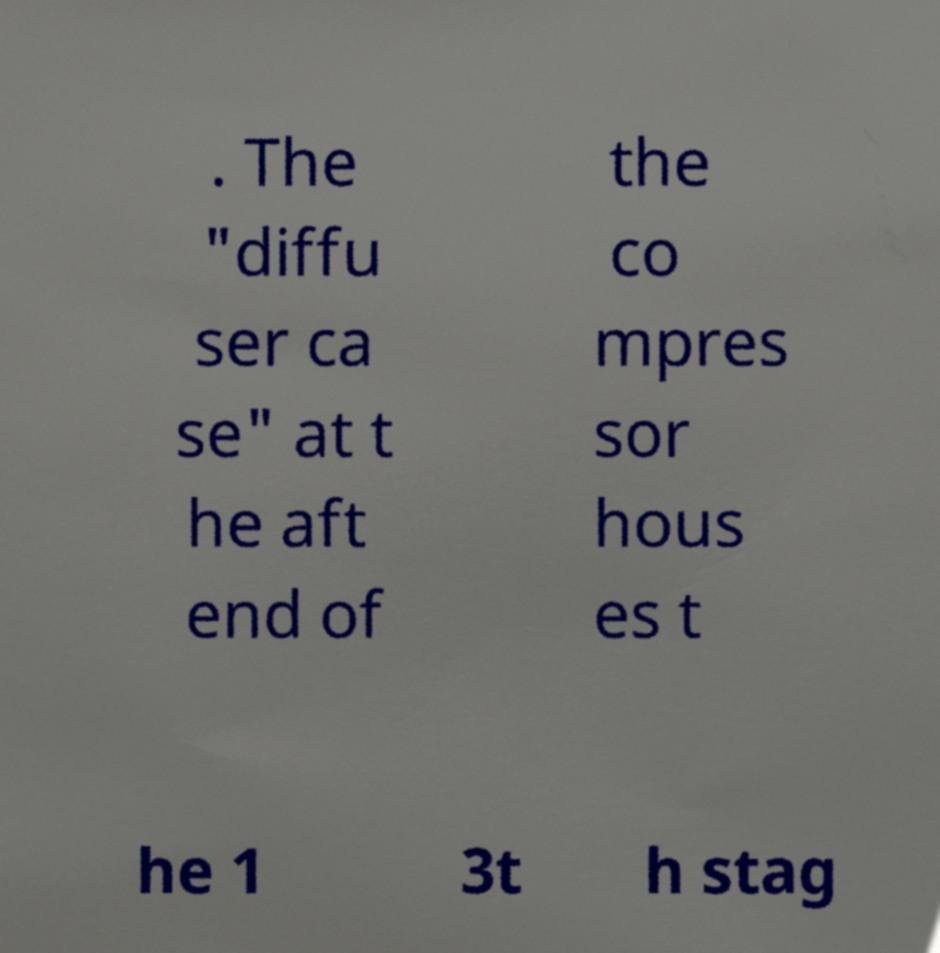Please read and relay the text visible in this image. What does it say? . The "diffu ser ca se" at t he aft end of the co mpres sor hous es t he 1 3t h stag 